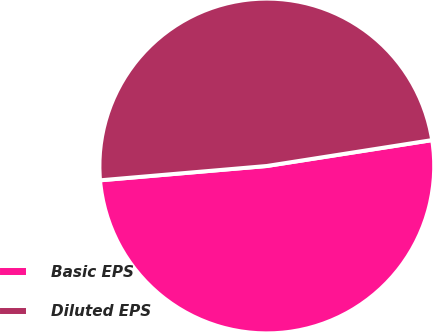Convert chart to OTSL. <chart><loc_0><loc_0><loc_500><loc_500><pie_chart><fcel>Basic EPS<fcel>Diluted EPS<nl><fcel>51.11%<fcel>48.89%<nl></chart> 